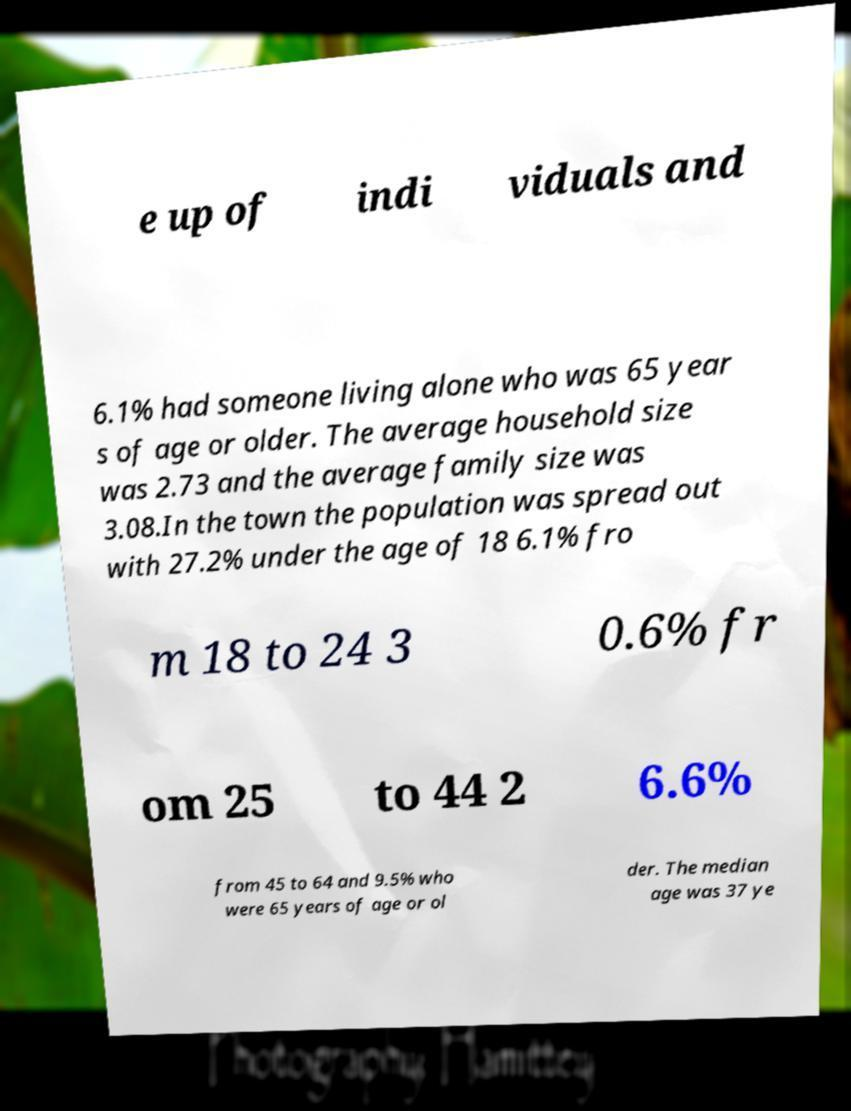Please read and relay the text visible in this image. What does it say? e up of indi viduals and 6.1% had someone living alone who was 65 year s of age or older. The average household size was 2.73 and the average family size was 3.08.In the town the population was spread out with 27.2% under the age of 18 6.1% fro m 18 to 24 3 0.6% fr om 25 to 44 2 6.6% from 45 to 64 and 9.5% who were 65 years of age or ol der. The median age was 37 ye 